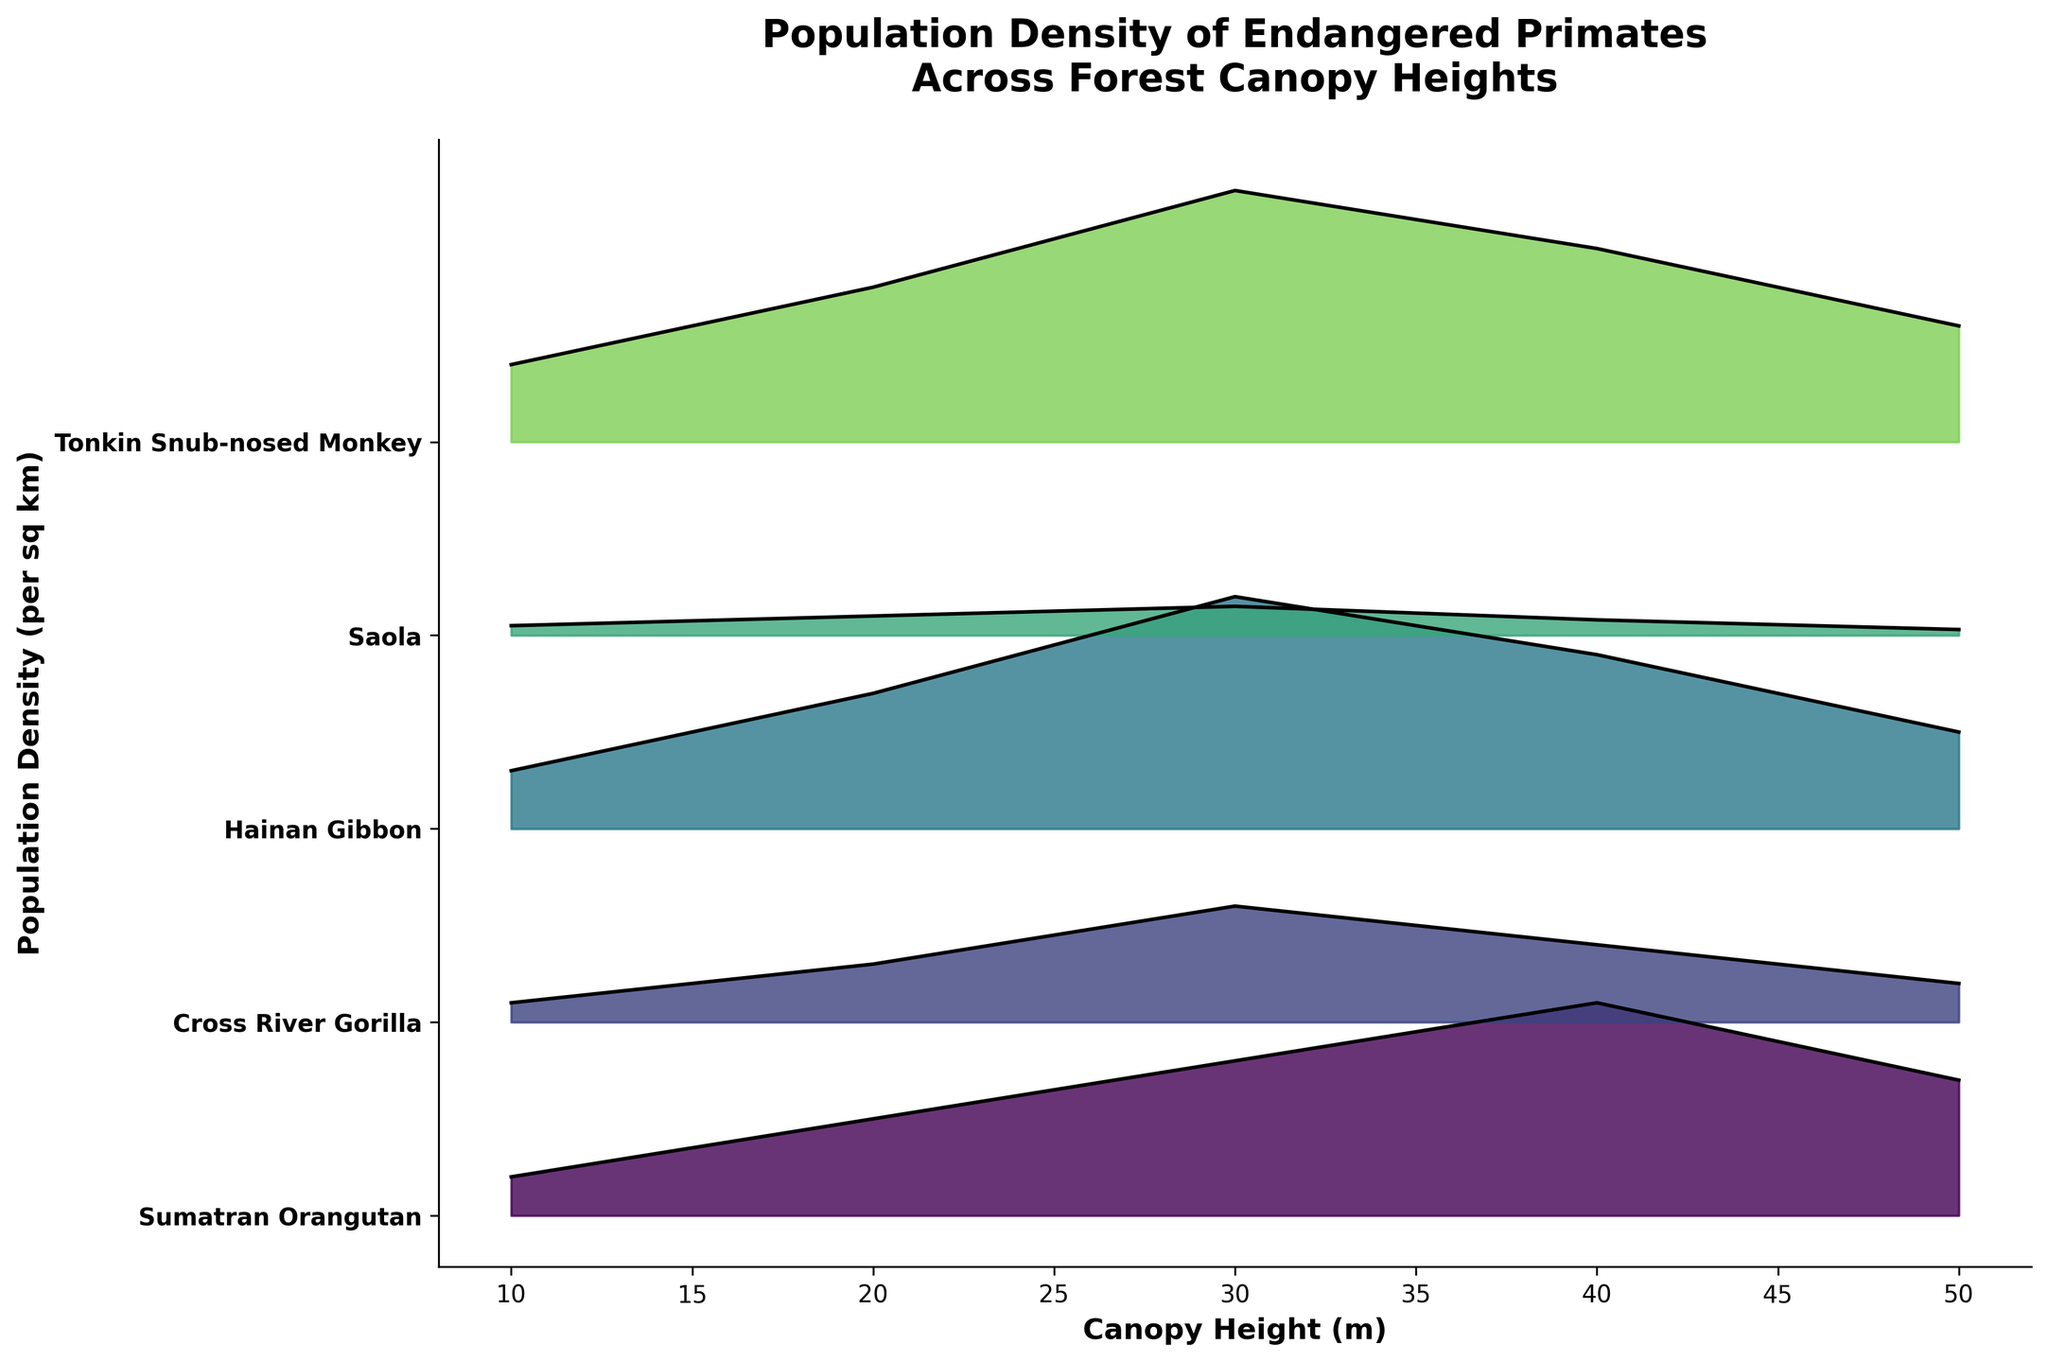What is the species with the highest population density at a canopy height of 30 meters? Look at the population density values along the vertical axis and find where the peak density for each species is at 30 meters. The Tonkin Snub-nosed Monkey has the highest density at 1.3.
Answer: Tonkin Snub-nosed Monkey Which species shows the steepest decrease in population density from 40 meters to 50 meters? Compare the change in population density from 40 meters to 50 meters for each species. The Saola shows a decrease from 0.08 to 0.03, a decrease of 0.05, which is the steepest decrease.
Answer: Saola What is the overall trend in population density for the Sumatran Orangutan as the canopy height increases from 10 meters to 50 meters? Observe the line for the Sumatran Orangutan across the canopy height range. The density increases from 0.2 to a peak of 1.1 at 40 meters and then decreases to 0.7 at 50 meters.
Answer: Increase then decrease How does the population density of Hainan Gibbon at 20 meters compare to its density at 50 meters? Compare the Hainan Gibbon's density at these canopy heights. At 20 meters it's 0.7 and at 50 meters it's 0.5, so there is a decrease.
Answer: Decreases Which species has the lowest population density at a canopy height of 10 meters? Check all species' density values at 10 meters. The Saola has the lowest density at 0.05.
Answer: Saola Is there any species for which the population density is highest at the canopy height of 10 meters? See if any species has its peak density at 10 meters. None of the species listed have their highest density at 10 meters.
Answer: No Among the specified species, which one shows the most consistent population density across different canopy heights? Compare the density fluctuations for each species across all canopy heights. The Cross River Gorilla shows the most consistent range from 0.1 to 0.6.
Answer: Cross River Gorilla At which canopy height does the Tonkin Snub-nosed Monkey reach its maximum population density? Find the highest density point for the Tonkin Snub-nosed Monkey. It reaches its maximum density of 1.3 at 30 meters.
Answer: 30 meters What are the two species with the highest population density at 10 meters and how do their densities compare? Identify species and their density at 10 meters. The Tonkin Snub-nosed Monkey has the highest at 0.4, followed by Hainan Gibbon at 0.3.
Answer: Tonkin Snub-nosed Monkey, Hainan Gibbon 